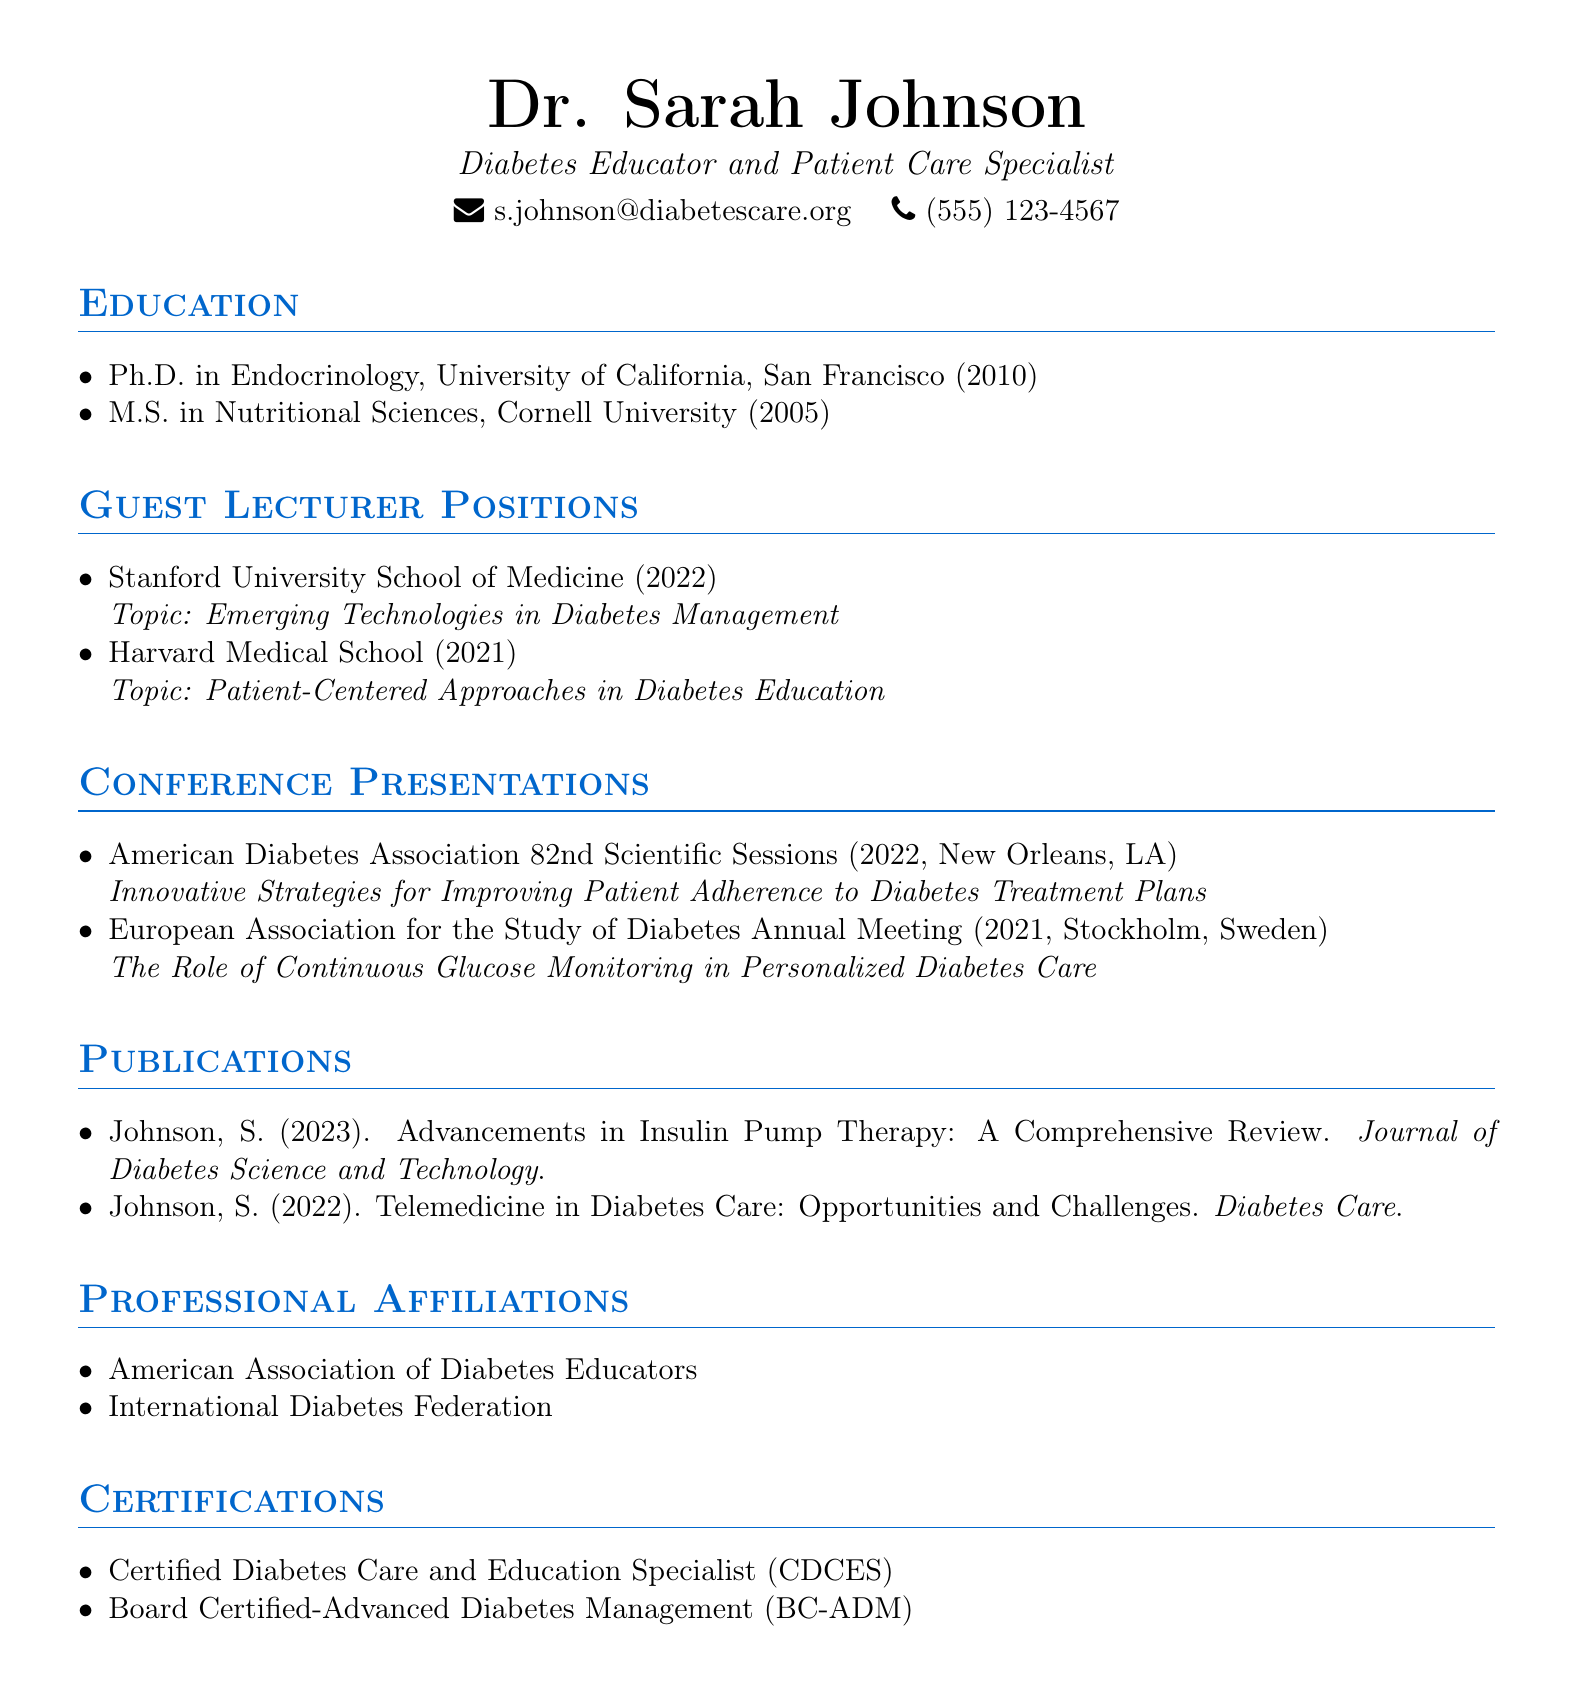What degree does Dr. Sarah Johnson hold? The highest degree listed is Ph.D. in Endocrinology from the University of California, San Francisco.
Answer: Ph.D. in Endocrinology In which year did Dr. Sarah Johnson complete her M.S. degree? The document states that the M.S. in Nutritional Sciences was completed in 2005.
Answer: 2005 What was the topic of the guest lecture at Stanford University School of Medicine? The document specifies that the topic was "Emerging Technologies in Diabetes Management."
Answer: Emerging Technologies in Diabetes Management How many conference presentations does Dr. Sarah Johnson have listed? The document enumerates a total of two conference presentations.
Answer: 2 At which conference did Dr. Sarah Johnson present in 2021? The content mentions the European Association for the Study of Diabetes Annual Meeting as the 2021 conference.
Answer: European Association for the Study of Diabetes Annual Meeting What certification does Dr. Sarah Johnson hold related to diabetes care? The document highlights that she is a Certified Diabetes Care and Education Specialist (CDCES).
Answer: Certified Diabetes Care and Education Specialist (CDCES) Which journal published Dr. Johnson’s 2023 article? The article titled "Advancements in Insulin Pump Therapy: A Comprehensive Review" was published in the Journal of Diabetes Science and Technology.
Answer: Journal of Diabetes Science and Technology What is Dr. Sarah Johnson's role as stated in her title? The title describes her as a Diabetes Educator and Patient Care Specialist.
Answer: Diabetes Educator and Patient Care Specialist How many professional affiliations are listed in the document? The document lists two professional affiliations for Dr. Sarah Johnson.
Answer: 2 What was the location of the American Diabetes Association conference where Dr. Johnson presented in 2022? The document specifies that the conference was held in New Orleans, LA.
Answer: New Orleans, LA 